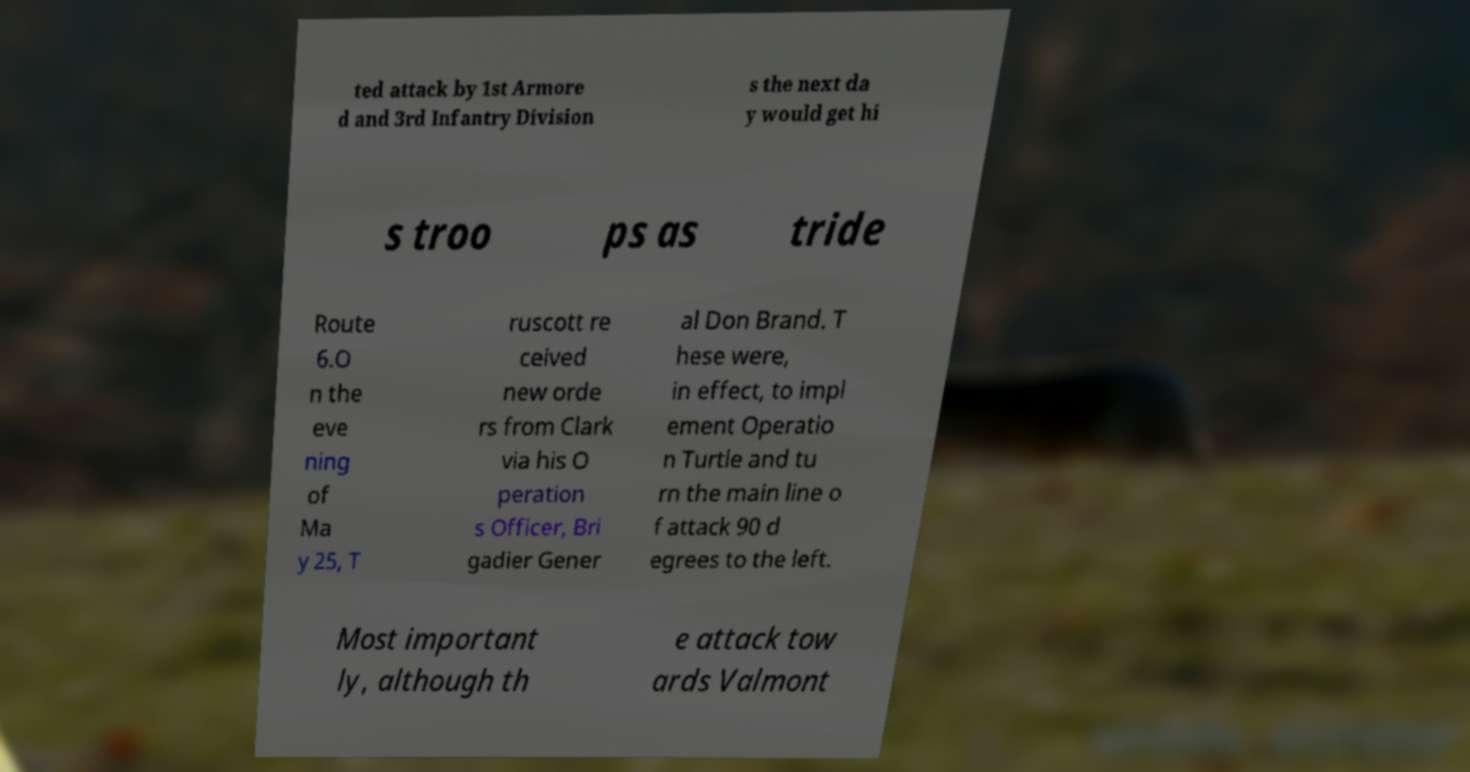I need the written content from this picture converted into text. Can you do that? ted attack by 1st Armore d and 3rd Infantry Division s the next da y would get hi s troo ps as tride Route 6.O n the eve ning of Ma y 25, T ruscott re ceived new orde rs from Clark via his O peration s Officer, Bri gadier Gener al Don Brand. T hese were, in effect, to impl ement Operatio n Turtle and tu rn the main line o f attack 90 d egrees to the left. Most important ly, although th e attack tow ards Valmont 